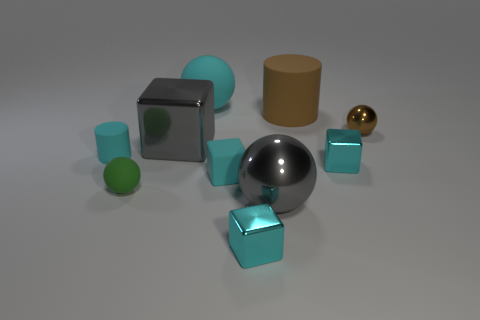Subtract all cyan cubes. How many were subtracted if there are1cyan cubes left? 2 Subtract all rubber blocks. How many blocks are left? 3 Subtract all brown cylinders. How many cylinders are left? 1 Subtract 2 spheres. How many spheres are left? 2 Subtract all red cubes. Subtract all green balls. How many cubes are left? 4 Subtract all cyan cylinders. How many blue balls are left? 0 Subtract all purple rubber things. Subtract all big rubber cylinders. How many objects are left? 9 Add 4 large brown things. How many large brown things are left? 5 Add 3 tiny cyan rubber blocks. How many tiny cyan rubber blocks exist? 4 Subtract 1 gray cubes. How many objects are left? 9 